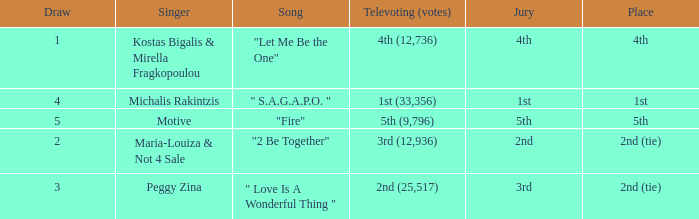Singer Maria-Louiza & Not 4 Sale had what jury? 2nd. 